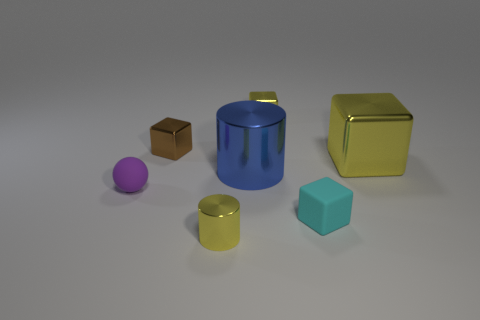Subtract all matte blocks. How many blocks are left? 3 Subtract all yellow blocks. How many blocks are left? 2 Add 2 tiny purple metallic objects. How many objects exist? 9 Subtract all cylinders. How many objects are left? 5 Subtract 2 cylinders. How many cylinders are left? 0 Subtract all large yellow metallic spheres. Subtract all tiny metal cubes. How many objects are left? 5 Add 4 small cyan things. How many small cyan things are left? 5 Add 3 large brown metallic cubes. How many large brown metallic cubes exist? 3 Subtract 0 cyan cylinders. How many objects are left? 7 Subtract all purple cylinders. Subtract all brown blocks. How many cylinders are left? 2 